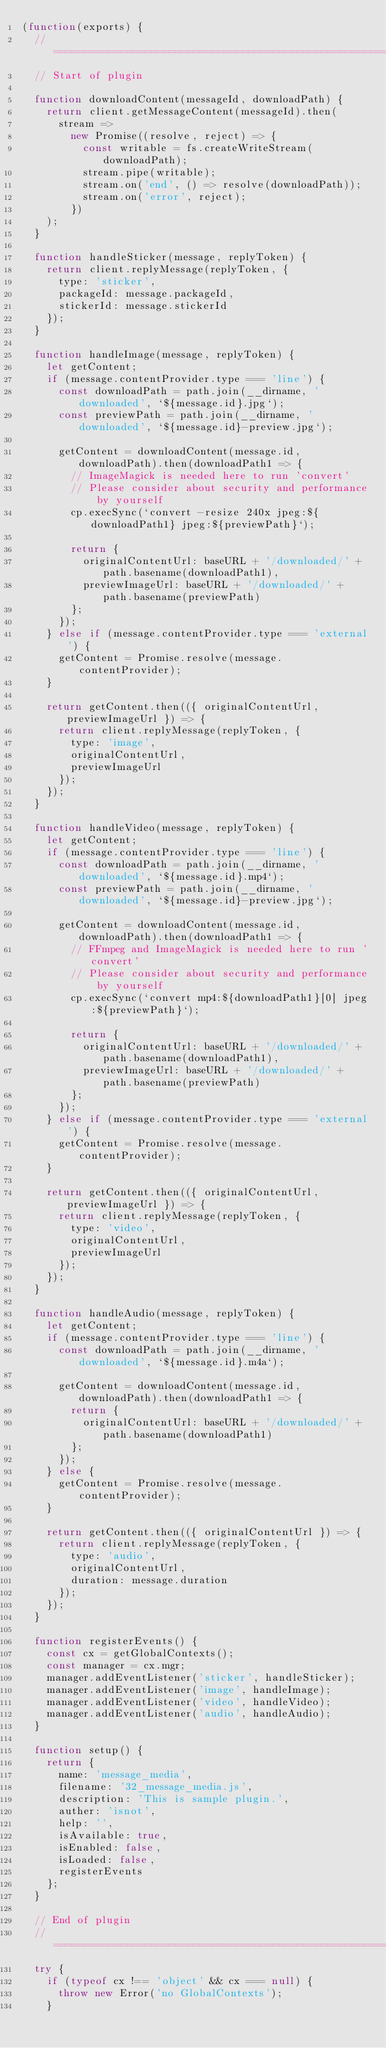<code> <loc_0><loc_0><loc_500><loc_500><_JavaScript_>(function(exports) {
  // =================================================================================
  // Start of plugin

  function downloadContent(messageId, downloadPath) {
    return client.getMessageContent(messageId).then(
      stream =>
        new Promise((resolve, reject) => {
          const writable = fs.createWriteStream(downloadPath);
          stream.pipe(writable);
          stream.on('end', () => resolve(downloadPath));
          stream.on('error', reject);
        })
    );
  }

  function handleSticker(message, replyToken) {
    return client.replyMessage(replyToken, {
      type: 'sticker',
      packageId: message.packageId,
      stickerId: message.stickerId
    });
  }

  function handleImage(message, replyToken) {
    let getContent;
    if (message.contentProvider.type === 'line') {
      const downloadPath = path.join(__dirname, 'downloaded', `${message.id}.jpg`);
      const previewPath = path.join(__dirname, 'downloaded', `${message.id}-preview.jpg`);

      getContent = downloadContent(message.id, downloadPath).then(downloadPath1 => {
        // ImageMagick is needed here to run 'convert'
        // Please consider about security and performance by yourself
        cp.execSync(`convert -resize 240x jpeg:${downloadPath1} jpeg:${previewPath}`);

        return {
          originalContentUrl: baseURL + '/downloaded/' + path.basename(downloadPath1),
          previewImageUrl: baseURL + '/downloaded/' + path.basename(previewPath)
        };
      });
    } else if (message.contentProvider.type === 'external') {
      getContent = Promise.resolve(message.contentProvider);
    }

    return getContent.then(({ originalContentUrl, previewImageUrl }) => {
      return client.replyMessage(replyToken, {
        type: 'image',
        originalContentUrl,
        previewImageUrl
      });
    });
  }

  function handleVideo(message, replyToken) {
    let getContent;
    if (message.contentProvider.type === 'line') {
      const downloadPath = path.join(__dirname, 'downloaded', `${message.id}.mp4`);
      const previewPath = path.join(__dirname, 'downloaded', `${message.id}-preview.jpg`);

      getContent = downloadContent(message.id, downloadPath).then(downloadPath1 => {
        // FFmpeg and ImageMagick is needed here to run 'convert'
        // Please consider about security and performance by yourself
        cp.execSync(`convert mp4:${downloadPath1}[0] jpeg:${previewPath}`);

        return {
          originalContentUrl: baseURL + '/downloaded/' + path.basename(downloadPath1),
          previewImageUrl: baseURL + '/downloaded/' + path.basename(previewPath)
        };
      });
    } else if (message.contentProvider.type === 'external') {
      getContent = Promise.resolve(message.contentProvider);
    }

    return getContent.then(({ originalContentUrl, previewImageUrl }) => {
      return client.replyMessage(replyToken, {
        type: 'video',
        originalContentUrl,
        previewImageUrl
      });
    });
  }

  function handleAudio(message, replyToken) {
    let getContent;
    if (message.contentProvider.type === 'line') {
      const downloadPath = path.join(__dirname, 'downloaded', `${message.id}.m4a`);

      getContent = downloadContent(message.id, downloadPath).then(downloadPath1 => {
        return {
          originalContentUrl: baseURL + '/downloaded/' + path.basename(downloadPath1)
        };
      });
    } else {
      getContent = Promise.resolve(message.contentProvider);
    }

    return getContent.then(({ originalContentUrl }) => {
      return client.replyMessage(replyToken, {
        type: 'audio',
        originalContentUrl,
        duration: message.duration
      });
    });
  }

  function registerEvents() {
    const cx = getGlobalContexts();
    const manager = cx.mgr;
    manager.addEventListener('sticker', handleSticker);
    manager.addEventListener('image', handleImage);
    manager.addEventListener('video', handleVideo);
    manager.addEventListener('audio', handleAudio);
  }

  function setup() {
    return {
      name: 'message_media',
      filename: '32_message_media.js',
      description: 'This is sample plugin.',
      auther: 'isnot',
      help: '',
      isAvailable: true,
      isEnabled: false,
      isLoaded: false,
      registerEvents
    };
  }

  // End of plugin
  // =================================================================================
  try {
    if (typeof cx !== 'object' && cx === null) {
      throw new Error('no GlobalContexts');
    }</code> 